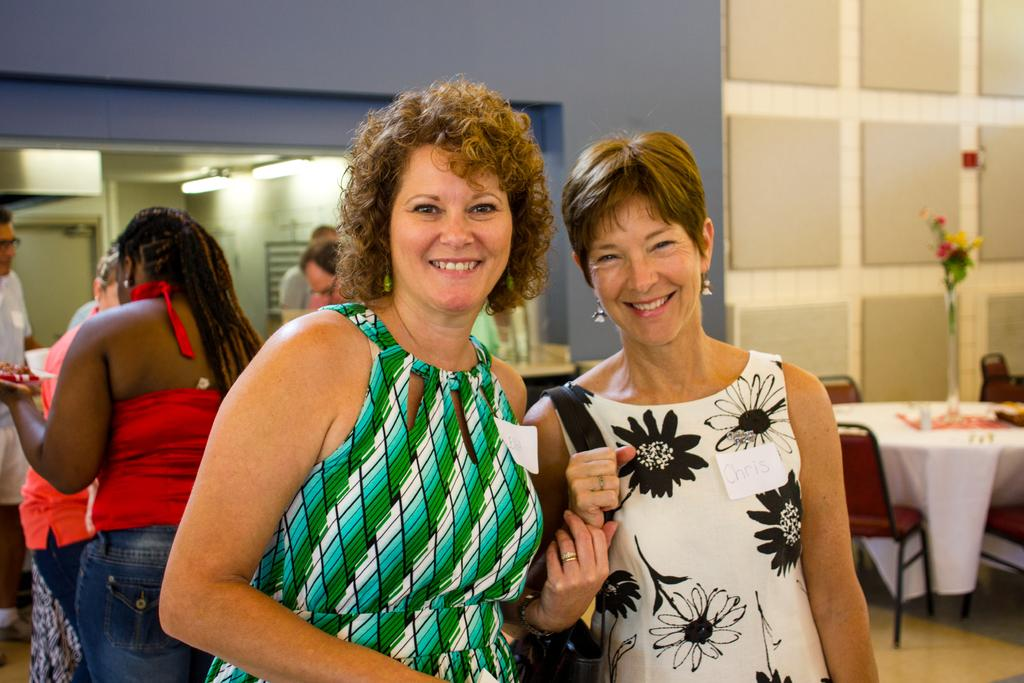How many women are in the image? There are two women in the image. What are the women doing in the image? The women are standing in front and smiling. Can you describe the background of the image? There are other humans in the background of the image. What furniture is present in the image? There is a table with chairs in the image. What decorative item can be seen on the table? There is a flower vase on the table. What historical discovery was made by the women in the image? There is no indication in the image that the women made any historical discovery. 